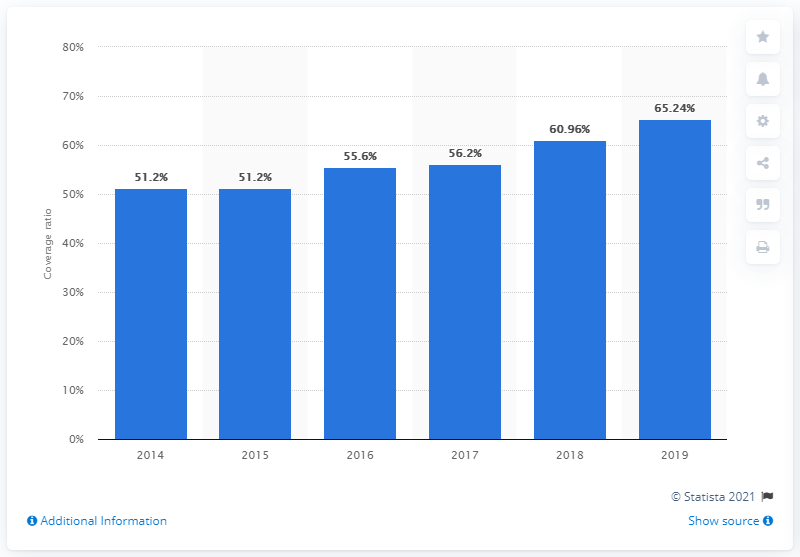Mention a couple of crucial points in this snapshot. In 2014, the coverage ratio of gross non-performing exposures for UniCredit was 51.2%. In 2019, the coverage ratio of gross non-performing exposures for UniCredit was 65.24%. 